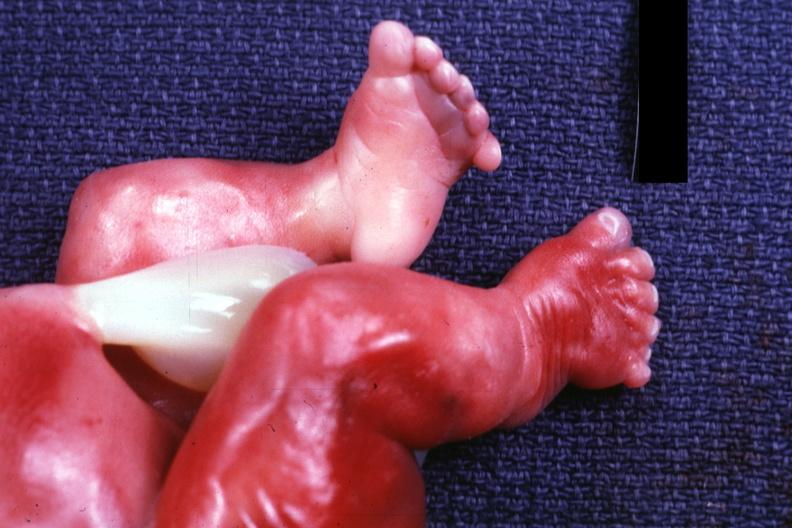re renal polycystic disease legs too short?
Answer the question using a single word or phrase. Yes 